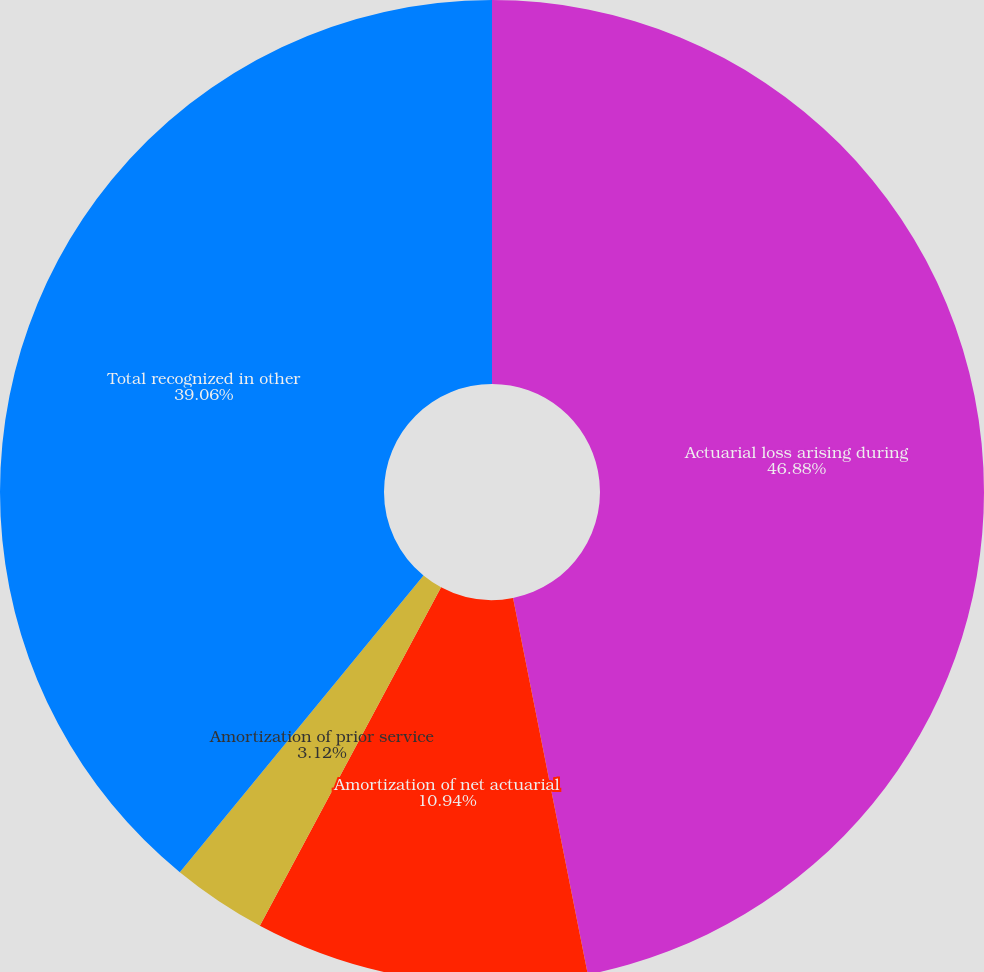Convert chart to OTSL. <chart><loc_0><loc_0><loc_500><loc_500><pie_chart><fcel>Actuarial loss arising during<fcel>Amortization of net actuarial<fcel>Amortization of prior service<fcel>Total recognized in other<nl><fcel>46.88%<fcel>10.94%<fcel>3.12%<fcel>39.06%<nl></chart> 